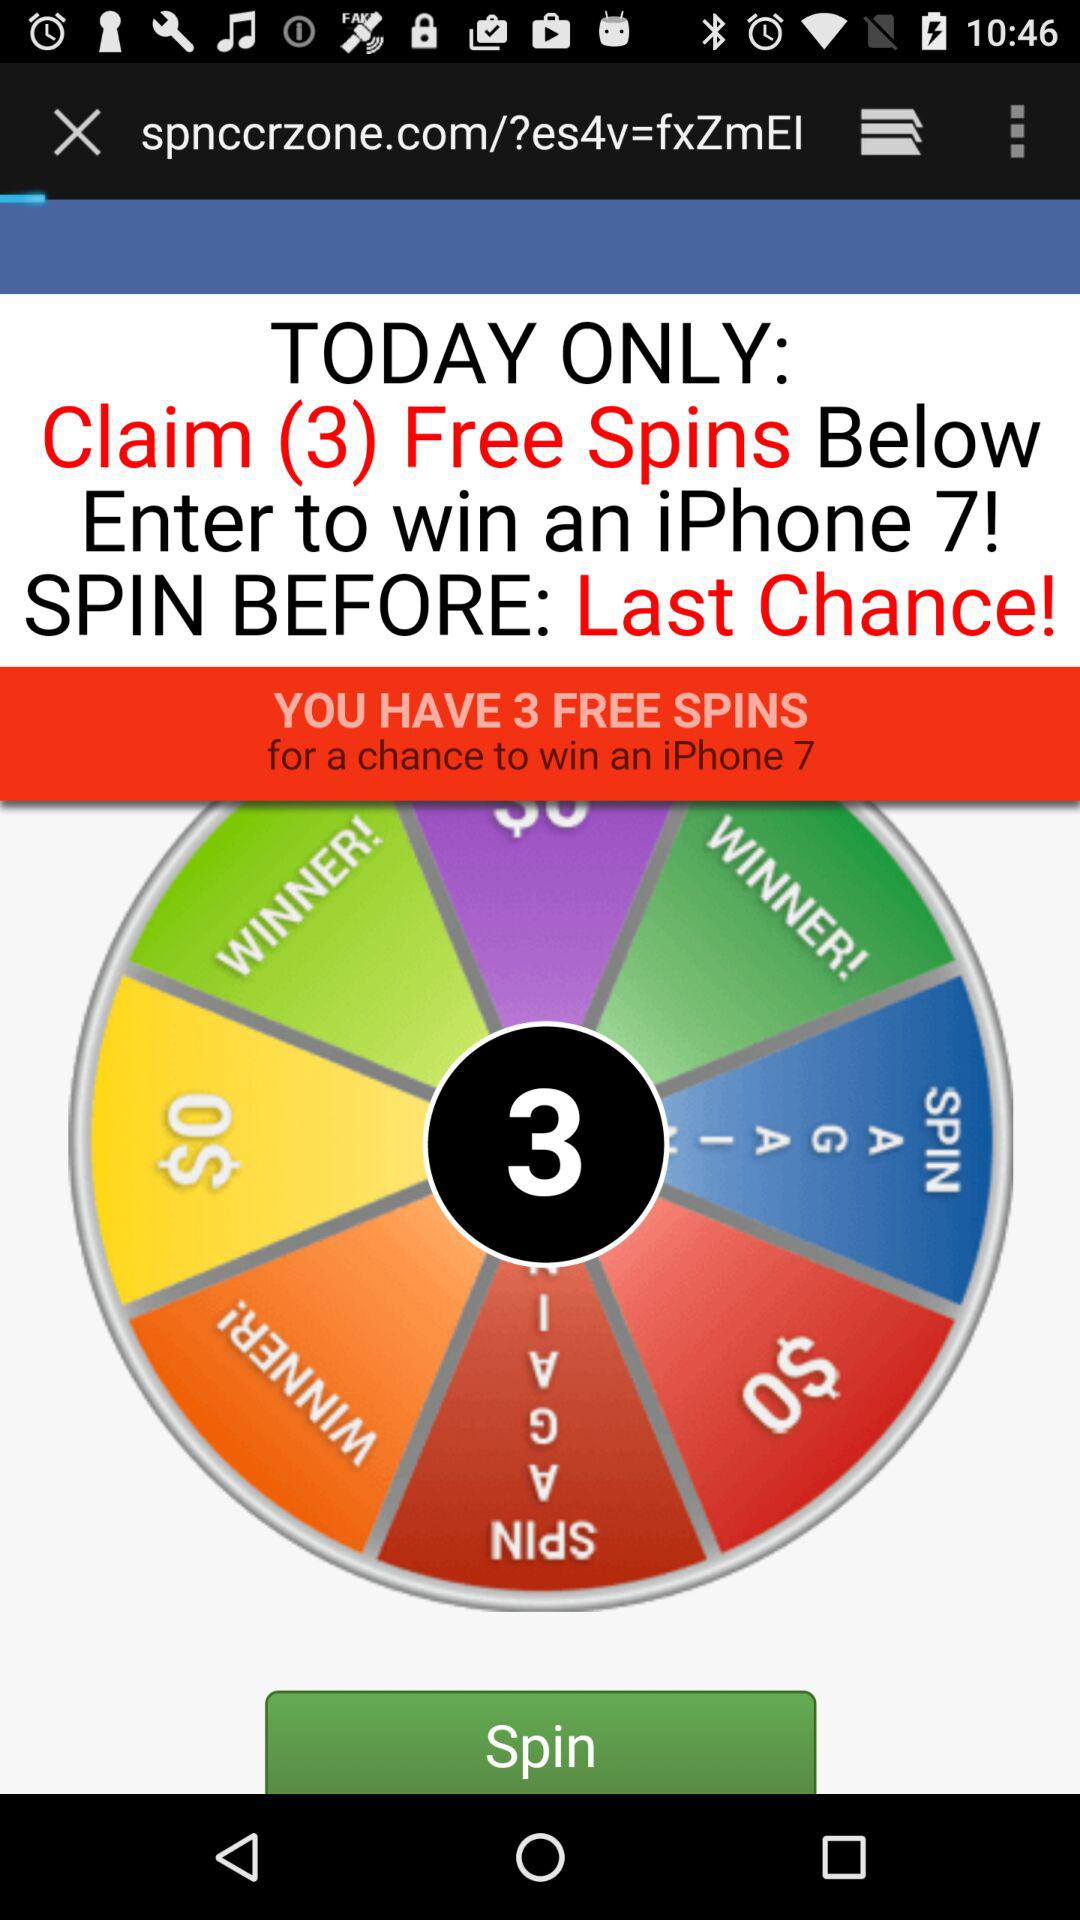How many free spins do we have? You have 3 free spins. 